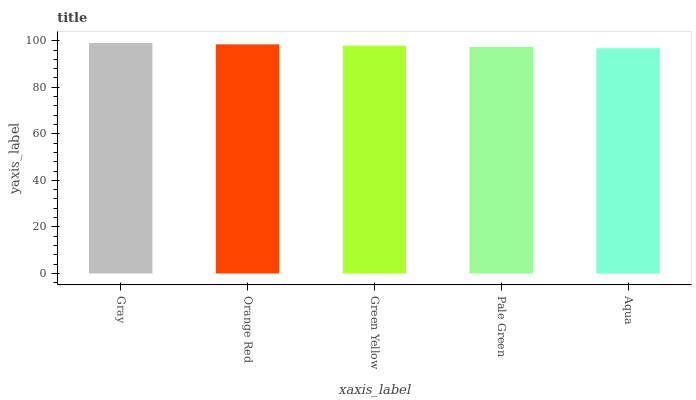Is Aqua the minimum?
Answer yes or no. Yes. Is Gray the maximum?
Answer yes or no. Yes. Is Orange Red the minimum?
Answer yes or no. No. Is Orange Red the maximum?
Answer yes or no. No. Is Gray greater than Orange Red?
Answer yes or no. Yes. Is Orange Red less than Gray?
Answer yes or no. Yes. Is Orange Red greater than Gray?
Answer yes or no. No. Is Gray less than Orange Red?
Answer yes or no. No. Is Green Yellow the high median?
Answer yes or no. Yes. Is Green Yellow the low median?
Answer yes or no. Yes. Is Aqua the high median?
Answer yes or no. No. Is Pale Green the low median?
Answer yes or no. No. 